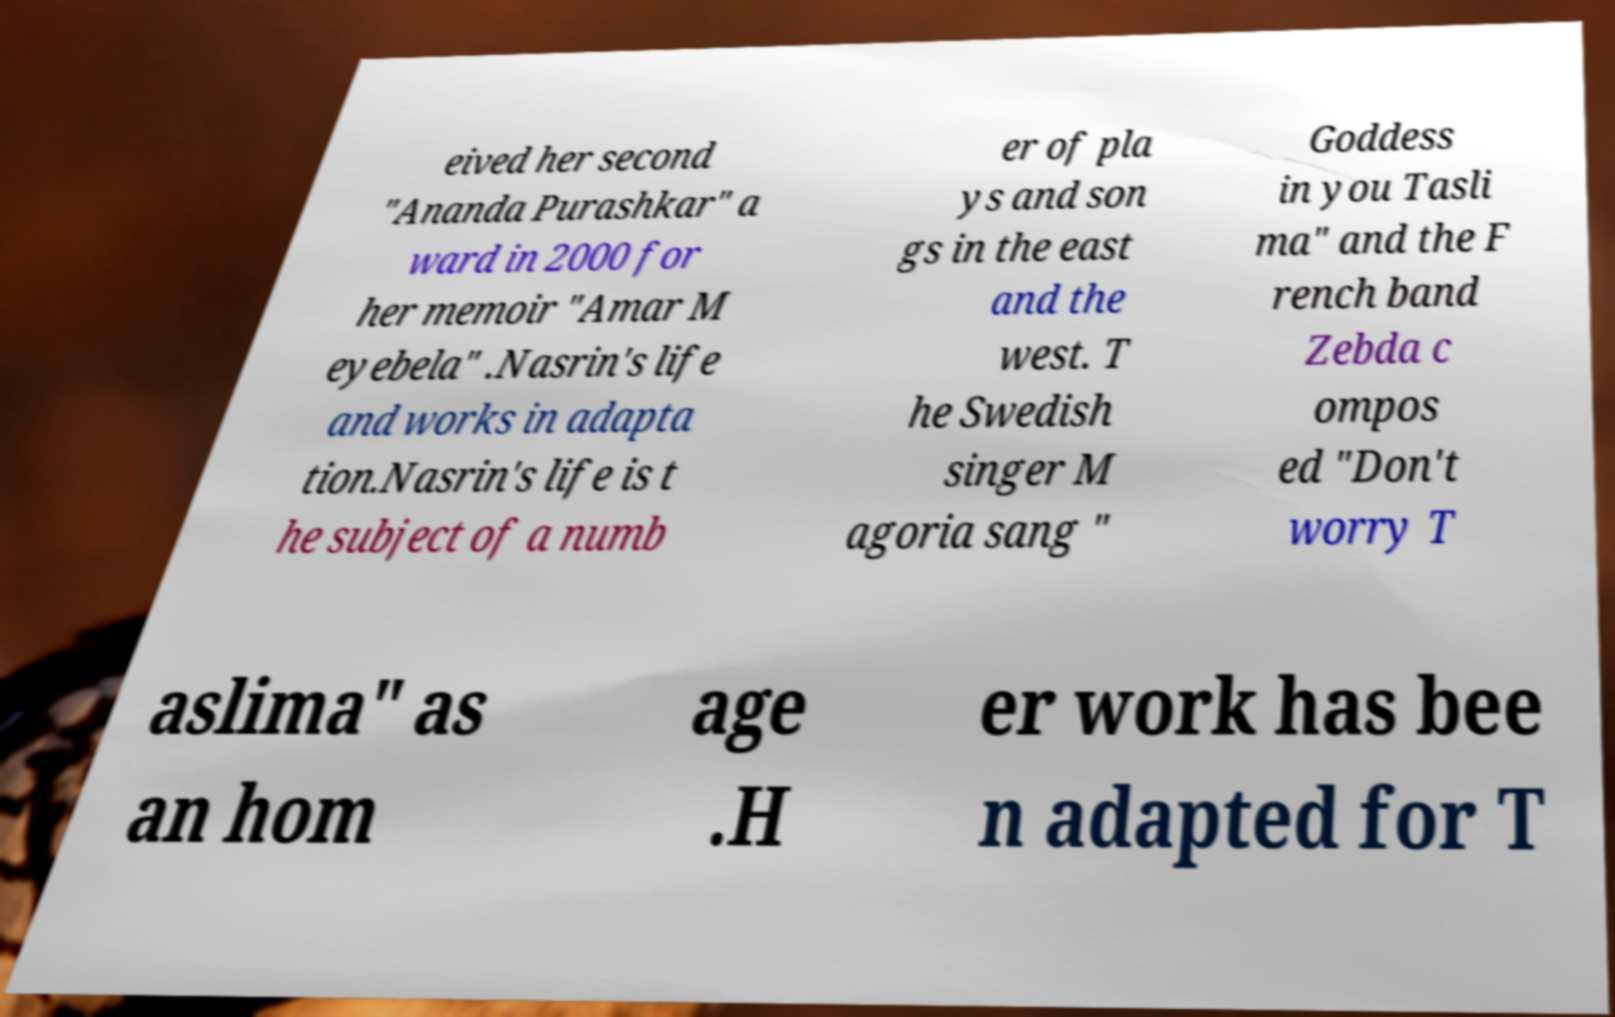For documentation purposes, I need the text within this image transcribed. Could you provide that? eived her second "Ananda Purashkar" a ward in 2000 for her memoir "Amar M eyebela" .Nasrin's life and works in adapta tion.Nasrin's life is t he subject of a numb er of pla ys and son gs in the east and the west. T he Swedish singer M agoria sang " Goddess in you Tasli ma" and the F rench band Zebda c ompos ed "Don't worry T aslima" as an hom age .H er work has bee n adapted for T 